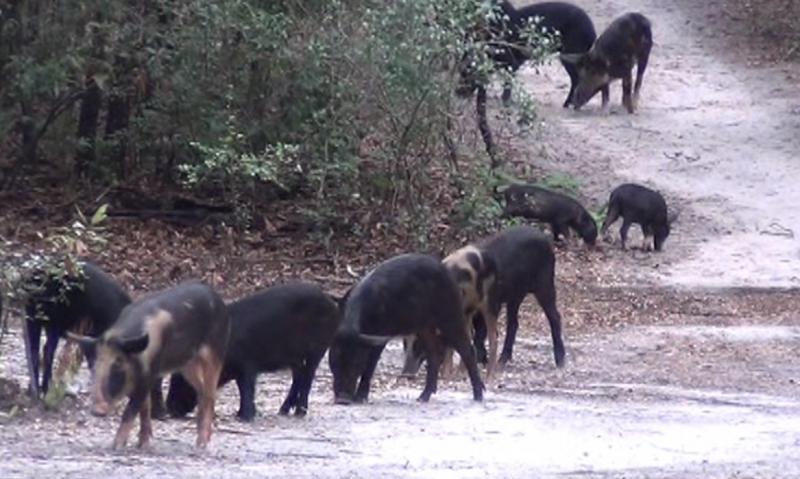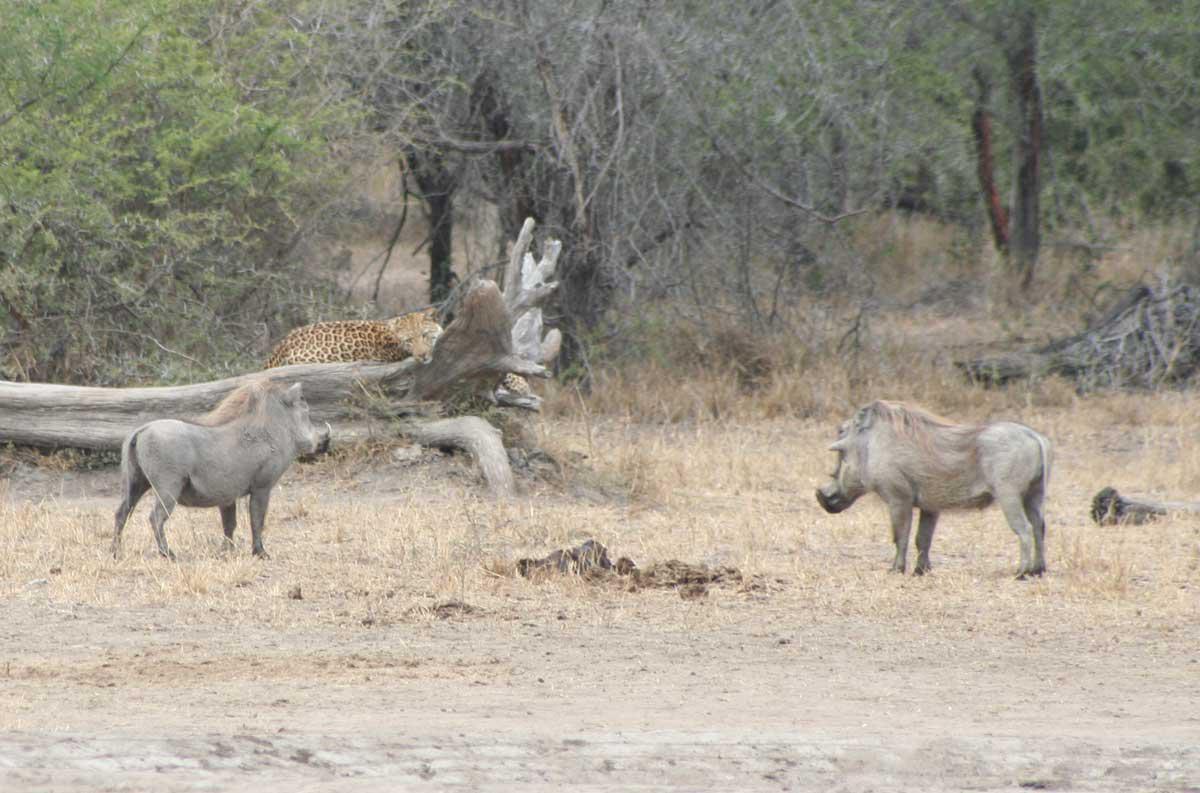The first image is the image on the left, the second image is the image on the right. For the images displayed, is the sentence "One or more boars are facing a predator in the right image." factually correct? Answer yes or no. Yes. The first image is the image on the left, the second image is the image on the right. Analyze the images presented: Is the assertion "Left image shows at least 8 dark hogs in a cleared area next to foliage." valid? Answer yes or no. Yes. 